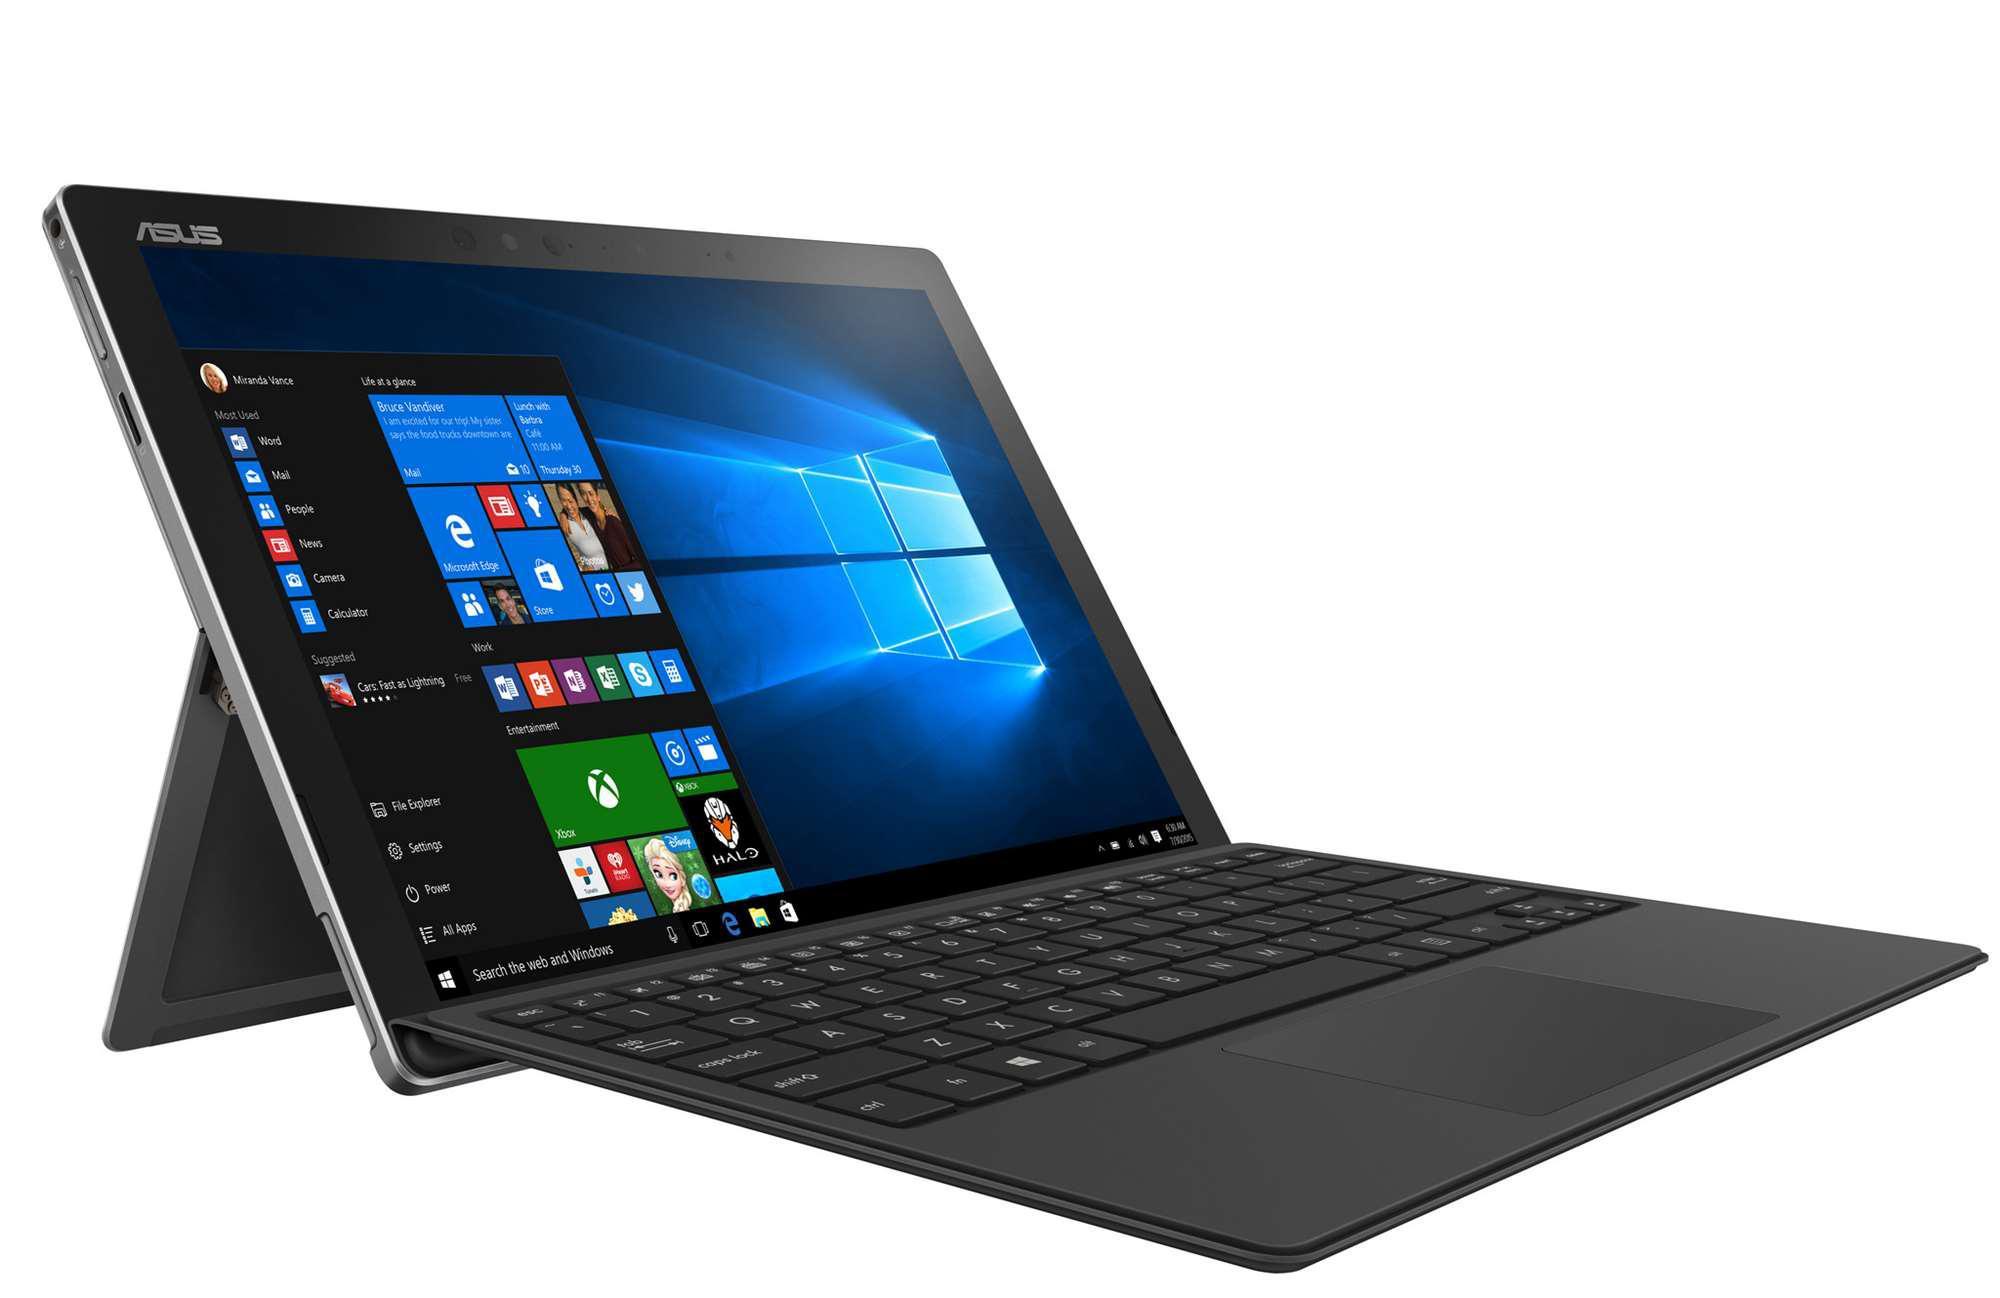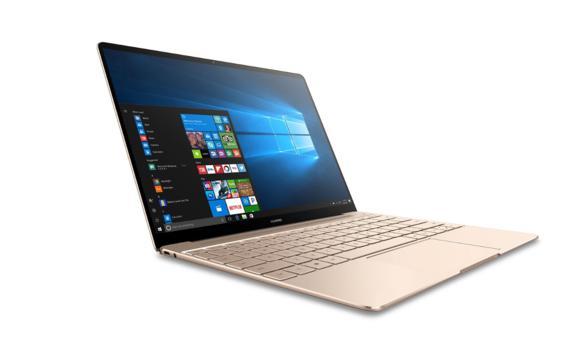The first image is the image on the left, the second image is the image on the right. Examine the images to the left and right. Is the description "Exactly three computers are shown in the left image and all three computers are open with a design shown on the screen." accurate? Answer yes or no. No. The first image is the image on the left, the second image is the image on the right. Examine the images to the left and right. Is the description "There are three laptops in at least one of the images." accurate? Answer yes or no. No. 